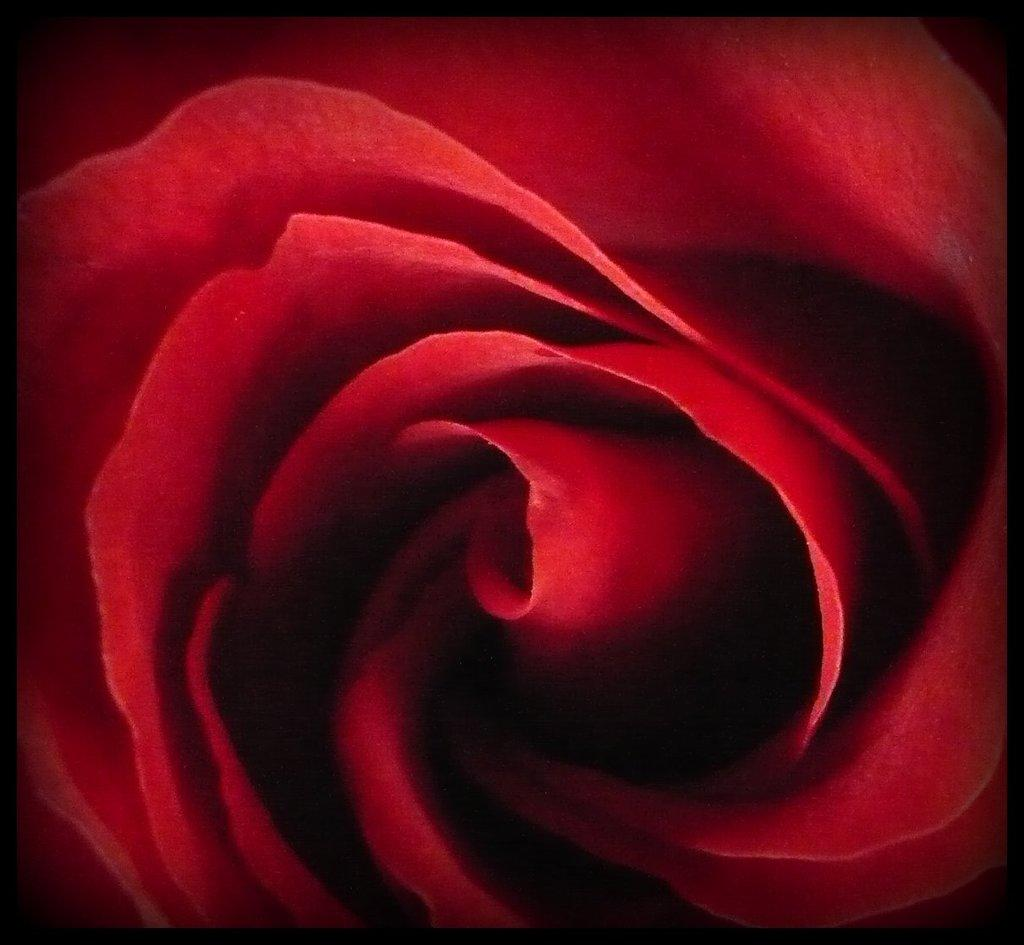What is the main subject of the image? The main subject of the image is a rose. Can you describe the rose in the image? The image is a zoomed in picture of a rose, so we can see the details of the petals and possibly the stem. What note is the rose playing in the image? There is no note being played in the image, as the subject is a rose and not a musical instrument. 